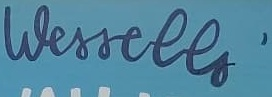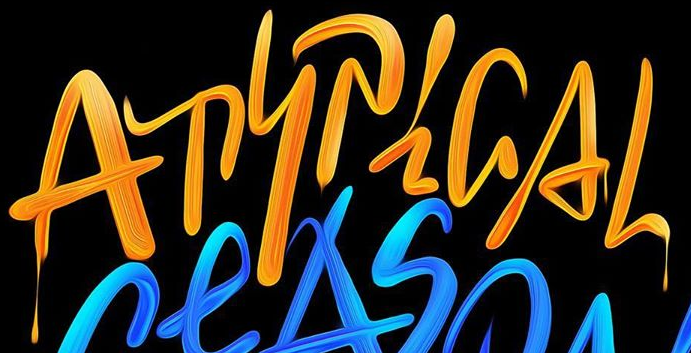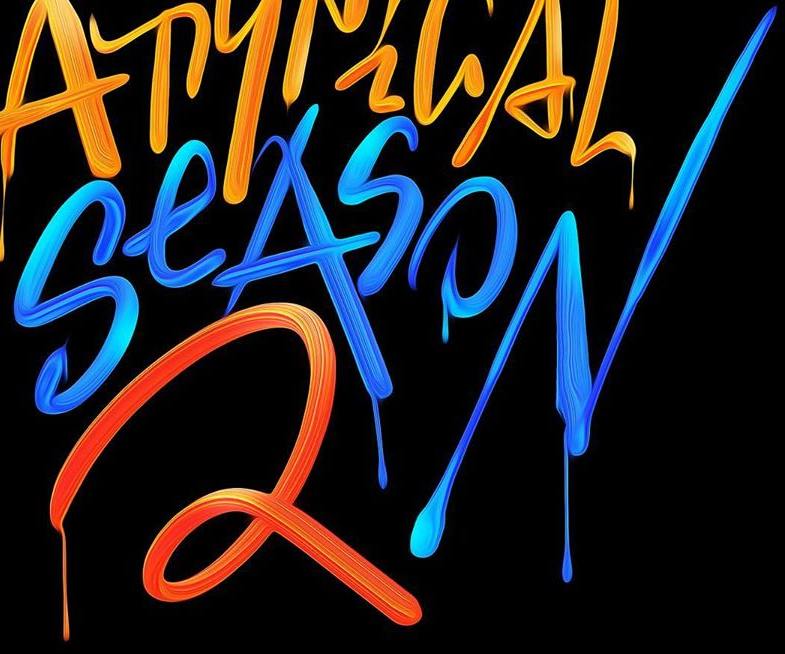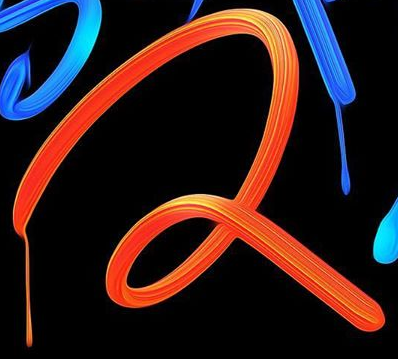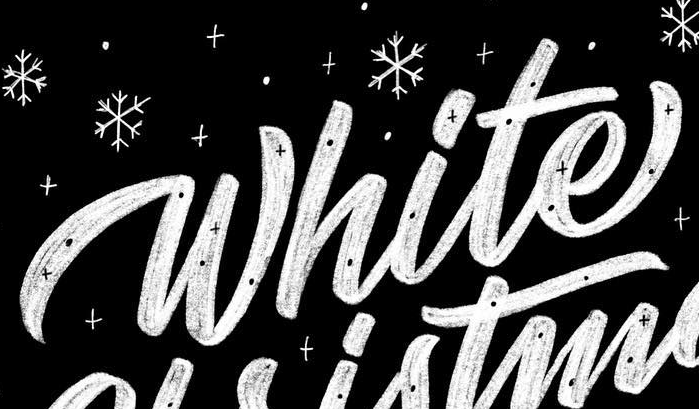What text appears in these images from left to right, separated by a semicolon? Wessells'; ATYPiGAL; SeASON; 2; White 